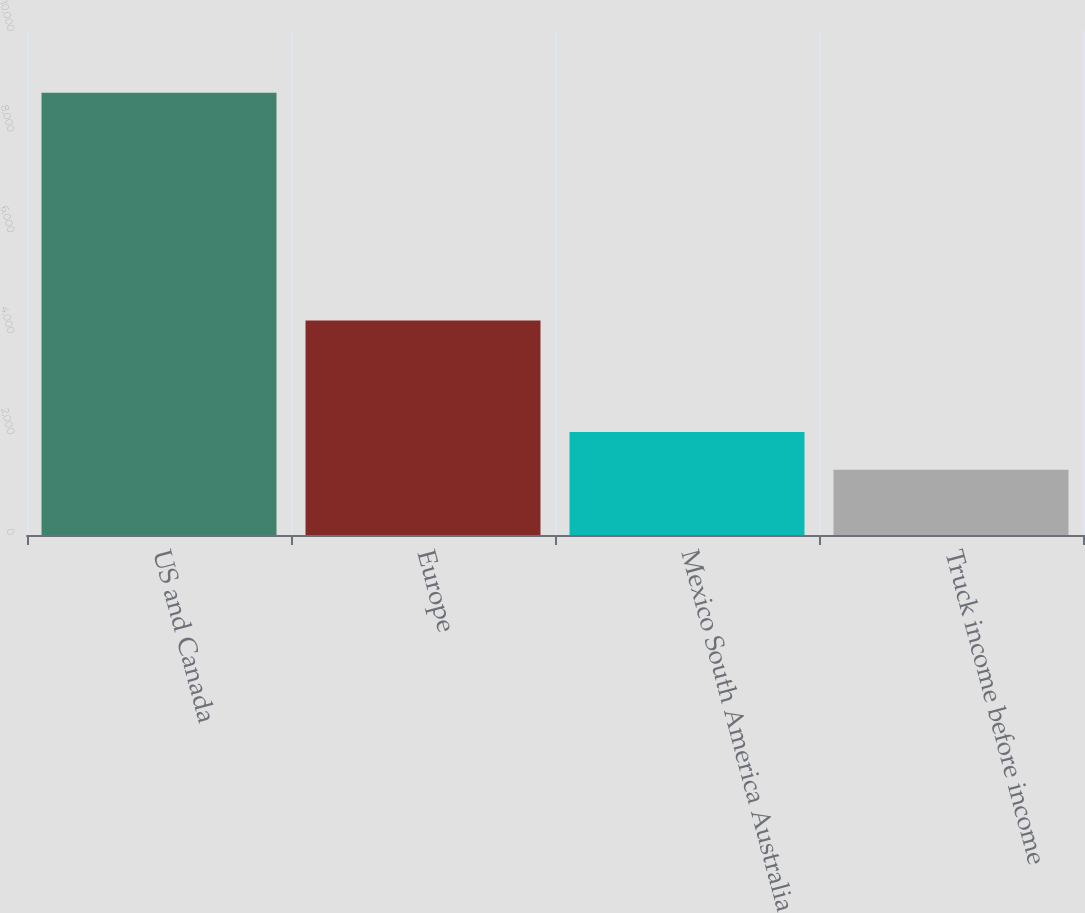Convert chart. <chart><loc_0><loc_0><loc_500><loc_500><bar_chart><fcel>US and Canada<fcel>Europe<fcel>Mexico South America Australia<fcel>Truck income before income<nl><fcel>8775.2<fcel>4254.9<fcel>2044.73<fcel>1296.9<nl></chart> 